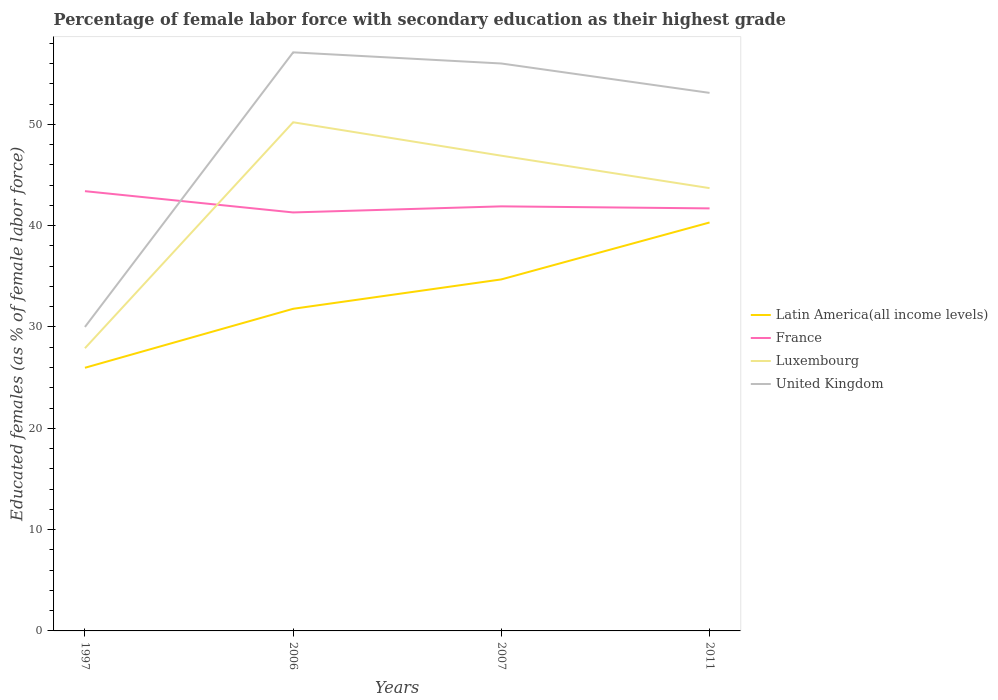How many different coloured lines are there?
Provide a succinct answer. 4. Is the number of lines equal to the number of legend labels?
Provide a succinct answer. Yes. Across all years, what is the maximum percentage of female labor force with secondary education in Latin America(all income levels)?
Your answer should be very brief. 25.97. In which year was the percentage of female labor force with secondary education in France maximum?
Offer a very short reply. 2006. What is the total percentage of female labor force with secondary education in Luxembourg in the graph?
Your answer should be very brief. -15.8. What is the difference between the highest and the second highest percentage of female labor force with secondary education in United Kingdom?
Your answer should be compact. 27.1. What is the difference between the highest and the lowest percentage of female labor force with secondary education in United Kingdom?
Give a very brief answer. 3. How many years are there in the graph?
Provide a succinct answer. 4. Are the values on the major ticks of Y-axis written in scientific E-notation?
Provide a short and direct response. No. Does the graph contain grids?
Your answer should be very brief. No. Where does the legend appear in the graph?
Provide a short and direct response. Center right. How many legend labels are there?
Provide a short and direct response. 4. How are the legend labels stacked?
Your response must be concise. Vertical. What is the title of the graph?
Provide a short and direct response. Percentage of female labor force with secondary education as their highest grade. What is the label or title of the Y-axis?
Provide a short and direct response. Educated females (as % of female labor force). What is the Educated females (as % of female labor force) of Latin America(all income levels) in 1997?
Your answer should be very brief. 25.97. What is the Educated females (as % of female labor force) in France in 1997?
Your answer should be very brief. 43.4. What is the Educated females (as % of female labor force) of Luxembourg in 1997?
Keep it short and to the point. 27.9. What is the Educated females (as % of female labor force) of Latin America(all income levels) in 2006?
Keep it short and to the point. 31.79. What is the Educated females (as % of female labor force) in France in 2006?
Your response must be concise. 41.3. What is the Educated females (as % of female labor force) of Luxembourg in 2006?
Your answer should be compact. 50.2. What is the Educated females (as % of female labor force) in United Kingdom in 2006?
Offer a terse response. 57.1. What is the Educated females (as % of female labor force) in Latin America(all income levels) in 2007?
Your answer should be compact. 34.69. What is the Educated females (as % of female labor force) of France in 2007?
Your answer should be very brief. 41.9. What is the Educated females (as % of female labor force) in Luxembourg in 2007?
Offer a very short reply. 46.9. What is the Educated females (as % of female labor force) of Latin America(all income levels) in 2011?
Give a very brief answer. 40.31. What is the Educated females (as % of female labor force) of France in 2011?
Offer a very short reply. 41.7. What is the Educated females (as % of female labor force) of Luxembourg in 2011?
Provide a succinct answer. 43.7. What is the Educated females (as % of female labor force) of United Kingdom in 2011?
Offer a very short reply. 53.1. Across all years, what is the maximum Educated females (as % of female labor force) in Latin America(all income levels)?
Ensure brevity in your answer.  40.31. Across all years, what is the maximum Educated females (as % of female labor force) in France?
Your answer should be compact. 43.4. Across all years, what is the maximum Educated females (as % of female labor force) of Luxembourg?
Your response must be concise. 50.2. Across all years, what is the maximum Educated females (as % of female labor force) in United Kingdom?
Give a very brief answer. 57.1. Across all years, what is the minimum Educated females (as % of female labor force) in Latin America(all income levels)?
Keep it short and to the point. 25.97. Across all years, what is the minimum Educated females (as % of female labor force) in France?
Provide a short and direct response. 41.3. Across all years, what is the minimum Educated females (as % of female labor force) in Luxembourg?
Provide a succinct answer. 27.9. Across all years, what is the minimum Educated females (as % of female labor force) of United Kingdom?
Provide a succinct answer. 30. What is the total Educated females (as % of female labor force) of Latin America(all income levels) in the graph?
Give a very brief answer. 132.76. What is the total Educated females (as % of female labor force) in France in the graph?
Provide a succinct answer. 168.3. What is the total Educated females (as % of female labor force) of Luxembourg in the graph?
Provide a short and direct response. 168.7. What is the total Educated females (as % of female labor force) of United Kingdom in the graph?
Offer a very short reply. 196.2. What is the difference between the Educated females (as % of female labor force) in Latin America(all income levels) in 1997 and that in 2006?
Provide a succinct answer. -5.82. What is the difference between the Educated females (as % of female labor force) of France in 1997 and that in 2006?
Your answer should be very brief. 2.1. What is the difference between the Educated females (as % of female labor force) in Luxembourg in 1997 and that in 2006?
Give a very brief answer. -22.3. What is the difference between the Educated females (as % of female labor force) of United Kingdom in 1997 and that in 2006?
Provide a succinct answer. -27.1. What is the difference between the Educated females (as % of female labor force) of Latin America(all income levels) in 1997 and that in 2007?
Ensure brevity in your answer.  -8.72. What is the difference between the Educated females (as % of female labor force) in Latin America(all income levels) in 1997 and that in 2011?
Your answer should be very brief. -14.34. What is the difference between the Educated females (as % of female labor force) in Luxembourg in 1997 and that in 2011?
Provide a short and direct response. -15.8. What is the difference between the Educated females (as % of female labor force) in United Kingdom in 1997 and that in 2011?
Make the answer very short. -23.1. What is the difference between the Educated females (as % of female labor force) of Latin America(all income levels) in 2006 and that in 2007?
Provide a short and direct response. -2.9. What is the difference between the Educated females (as % of female labor force) in United Kingdom in 2006 and that in 2007?
Provide a succinct answer. 1.1. What is the difference between the Educated females (as % of female labor force) in Latin America(all income levels) in 2006 and that in 2011?
Your answer should be very brief. -8.52. What is the difference between the Educated females (as % of female labor force) in France in 2006 and that in 2011?
Offer a very short reply. -0.4. What is the difference between the Educated females (as % of female labor force) of Luxembourg in 2006 and that in 2011?
Provide a succinct answer. 6.5. What is the difference between the Educated females (as % of female labor force) of United Kingdom in 2006 and that in 2011?
Make the answer very short. 4. What is the difference between the Educated females (as % of female labor force) in Latin America(all income levels) in 2007 and that in 2011?
Provide a short and direct response. -5.62. What is the difference between the Educated females (as % of female labor force) of Luxembourg in 2007 and that in 2011?
Provide a succinct answer. 3.2. What is the difference between the Educated females (as % of female labor force) of United Kingdom in 2007 and that in 2011?
Offer a very short reply. 2.9. What is the difference between the Educated females (as % of female labor force) in Latin America(all income levels) in 1997 and the Educated females (as % of female labor force) in France in 2006?
Give a very brief answer. -15.33. What is the difference between the Educated females (as % of female labor force) of Latin America(all income levels) in 1997 and the Educated females (as % of female labor force) of Luxembourg in 2006?
Provide a short and direct response. -24.23. What is the difference between the Educated females (as % of female labor force) of Latin America(all income levels) in 1997 and the Educated females (as % of female labor force) of United Kingdom in 2006?
Keep it short and to the point. -31.13. What is the difference between the Educated females (as % of female labor force) in France in 1997 and the Educated females (as % of female labor force) in United Kingdom in 2006?
Provide a succinct answer. -13.7. What is the difference between the Educated females (as % of female labor force) in Luxembourg in 1997 and the Educated females (as % of female labor force) in United Kingdom in 2006?
Offer a very short reply. -29.2. What is the difference between the Educated females (as % of female labor force) in Latin America(all income levels) in 1997 and the Educated females (as % of female labor force) in France in 2007?
Make the answer very short. -15.93. What is the difference between the Educated females (as % of female labor force) in Latin America(all income levels) in 1997 and the Educated females (as % of female labor force) in Luxembourg in 2007?
Ensure brevity in your answer.  -20.93. What is the difference between the Educated females (as % of female labor force) of Latin America(all income levels) in 1997 and the Educated females (as % of female labor force) of United Kingdom in 2007?
Your answer should be very brief. -30.03. What is the difference between the Educated females (as % of female labor force) of Luxembourg in 1997 and the Educated females (as % of female labor force) of United Kingdom in 2007?
Offer a terse response. -28.1. What is the difference between the Educated females (as % of female labor force) in Latin America(all income levels) in 1997 and the Educated females (as % of female labor force) in France in 2011?
Offer a very short reply. -15.73. What is the difference between the Educated females (as % of female labor force) in Latin America(all income levels) in 1997 and the Educated females (as % of female labor force) in Luxembourg in 2011?
Offer a very short reply. -17.73. What is the difference between the Educated females (as % of female labor force) in Latin America(all income levels) in 1997 and the Educated females (as % of female labor force) in United Kingdom in 2011?
Ensure brevity in your answer.  -27.13. What is the difference between the Educated females (as % of female labor force) in France in 1997 and the Educated females (as % of female labor force) in Luxembourg in 2011?
Provide a succinct answer. -0.3. What is the difference between the Educated females (as % of female labor force) of Luxembourg in 1997 and the Educated females (as % of female labor force) of United Kingdom in 2011?
Your answer should be very brief. -25.2. What is the difference between the Educated females (as % of female labor force) in Latin America(all income levels) in 2006 and the Educated females (as % of female labor force) in France in 2007?
Your response must be concise. -10.11. What is the difference between the Educated females (as % of female labor force) in Latin America(all income levels) in 2006 and the Educated females (as % of female labor force) in Luxembourg in 2007?
Provide a succinct answer. -15.11. What is the difference between the Educated females (as % of female labor force) in Latin America(all income levels) in 2006 and the Educated females (as % of female labor force) in United Kingdom in 2007?
Your response must be concise. -24.21. What is the difference between the Educated females (as % of female labor force) of France in 2006 and the Educated females (as % of female labor force) of United Kingdom in 2007?
Provide a succinct answer. -14.7. What is the difference between the Educated females (as % of female labor force) in Luxembourg in 2006 and the Educated females (as % of female labor force) in United Kingdom in 2007?
Make the answer very short. -5.8. What is the difference between the Educated females (as % of female labor force) of Latin America(all income levels) in 2006 and the Educated females (as % of female labor force) of France in 2011?
Your response must be concise. -9.91. What is the difference between the Educated females (as % of female labor force) of Latin America(all income levels) in 2006 and the Educated females (as % of female labor force) of Luxembourg in 2011?
Provide a short and direct response. -11.91. What is the difference between the Educated females (as % of female labor force) of Latin America(all income levels) in 2006 and the Educated females (as % of female labor force) of United Kingdom in 2011?
Give a very brief answer. -21.31. What is the difference between the Educated females (as % of female labor force) of France in 2006 and the Educated females (as % of female labor force) of Luxembourg in 2011?
Keep it short and to the point. -2.4. What is the difference between the Educated females (as % of female labor force) of France in 2006 and the Educated females (as % of female labor force) of United Kingdom in 2011?
Offer a terse response. -11.8. What is the difference between the Educated females (as % of female labor force) in Luxembourg in 2006 and the Educated females (as % of female labor force) in United Kingdom in 2011?
Your response must be concise. -2.9. What is the difference between the Educated females (as % of female labor force) of Latin America(all income levels) in 2007 and the Educated females (as % of female labor force) of France in 2011?
Ensure brevity in your answer.  -7.01. What is the difference between the Educated females (as % of female labor force) in Latin America(all income levels) in 2007 and the Educated females (as % of female labor force) in Luxembourg in 2011?
Offer a terse response. -9.01. What is the difference between the Educated females (as % of female labor force) in Latin America(all income levels) in 2007 and the Educated females (as % of female labor force) in United Kingdom in 2011?
Your response must be concise. -18.41. What is the difference between the Educated females (as % of female labor force) of France in 2007 and the Educated females (as % of female labor force) of United Kingdom in 2011?
Provide a succinct answer. -11.2. What is the average Educated females (as % of female labor force) of Latin America(all income levels) per year?
Provide a succinct answer. 33.19. What is the average Educated females (as % of female labor force) in France per year?
Offer a very short reply. 42.08. What is the average Educated females (as % of female labor force) in Luxembourg per year?
Give a very brief answer. 42.17. What is the average Educated females (as % of female labor force) of United Kingdom per year?
Your answer should be compact. 49.05. In the year 1997, what is the difference between the Educated females (as % of female labor force) of Latin America(all income levels) and Educated females (as % of female labor force) of France?
Offer a very short reply. -17.43. In the year 1997, what is the difference between the Educated females (as % of female labor force) in Latin America(all income levels) and Educated females (as % of female labor force) in Luxembourg?
Your answer should be very brief. -1.93. In the year 1997, what is the difference between the Educated females (as % of female labor force) in Latin America(all income levels) and Educated females (as % of female labor force) in United Kingdom?
Your answer should be very brief. -4.03. In the year 2006, what is the difference between the Educated females (as % of female labor force) of Latin America(all income levels) and Educated females (as % of female labor force) of France?
Give a very brief answer. -9.51. In the year 2006, what is the difference between the Educated females (as % of female labor force) in Latin America(all income levels) and Educated females (as % of female labor force) in Luxembourg?
Offer a very short reply. -18.41. In the year 2006, what is the difference between the Educated females (as % of female labor force) of Latin America(all income levels) and Educated females (as % of female labor force) of United Kingdom?
Make the answer very short. -25.31. In the year 2006, what is the difference between the Educated females (as % of female labor force) in France and Educated females (as % of female labor force) in United Kingdom?
Offer a terse response. -15.8. In the year 2007, what is the difference between the Educated females (as % of female labor force) of Latin America(all income levels) and Educated females (as % of female labor force) of France?
Offer a terse response. -7.21. In the year 2007, what is the difference between the Educated females (as % of female labor force) in Latin America(all income levels) and Educated females (as % of female labor force) in Luxembourg?
Offer a terse response. -12.21. In the year 2007, what is the difference between the Educated females (as % of female labor force) in Latin America(all income levels) and Educated females (as % of female labor force) in United Kingdom?
Provide a short and direct response. -21.31. In the year 2007, what is the difference between the Educated females (as % of female labor force) of France and Educated females (as % of female labor force) of United Kingdom?
Give a very brief answer. -14.1. In the year 2011, what is the difference between the Educated females (as % of female labor force) in Latin America(all income levels) and Educated females (as % of female labor force) in France?
Your response must be concise. -1.39. In the year 2011, what is the difference between the Educated females (as % of female labor force) of Latin America(all income levels) and Educated females (as % of female labor force) of Luxembourg?
Make the answer very short. -3.39. In the year 2011, what is the difference between the Educated females (as % of female labor force) in Latin America(all income levels) and Educated females (as % of female labor force) in United Kingdom?
Ensure brevity in your answer.  -12.79. In the year 2011, what is the difference between the Educated females (as % of female labor force) in France and Educated females (as % of female labor force) in Luxembourg?
Ensure brevity in your answer.  -2. In the year 2011, what is the difference between the Educated females (as % of female labor force) in Luxembourg and Educated females (as % of female labor force) in United Kingdom?
Your answer should be very brief. -9.4. What is the ratio of the Educated females (as % of female labor force) in Latin America(all income levels) in 1997 to that in 2006?
Ensure brevity in your answer.  0.82. What is the ratio of the Educated females (as % of female labor force) of France in 1997 to that in 2006?
Your answer should be compact. 1.05. What is the ratio of the Educated females (as % of female labor force) of Luxembourg in 1997 to that in 2006?
Your answer should be compact. 0.56. What is the ratio of the Educated females (as % of female labor force) of United Kingdom in 1997 to that in 2006?
Provide a succinct answer. 0.53. What is the ratio of the Educated females (as % of female labor force) of Latin America(all income levels) in 1997 to that in 2007?
Ensure brevity in your answer.  0.75. What is the ratio of the Educated females (as % of female labor force) of France in 1997 to that in 2007?
Your answer should be very brief. 1.04. What is the ratio of the Educated females (as % of female labor force) in Luxembourg in 1997 to that in 2007?
Make the answer very short. 0.59. What is the ratio of the Educated females (as % of female labor force) in United Kingdom in 1997 to that in 2007?
Keep it short and to the point. 0.54. What is the ratio of the Educated females (as % of female labor force) in Latin America(all income levels) in 1997 to that in 2011?
Provide a succinct answer. 0.64. What is the ratio of the Educated females (as % of female labor force) in France in 1997 to that in 2011?
Your answer should be very brief. 1.04. What is the ratio of the Educated females (as % of female labor force) of Luxembourg in 1997 to that in 2011?
Provide a succinct answer. 0.64. What is the ratio of the Educated females (as % of female labor force) of United Kingdom in 1997 to that in 2011?
Ensure brevity in your answer.  0.56. What is the ratio of the Educated females (as % of female labor force) of Latin America(all income levels) in 2006 to that in 2007?
Your answer should be very brief. 0.92. What is the ratio of the Educated females (as % of female labor force) in France in 2006 to that in 2007?
Your response must be concise. 0.99. What is the ratio of the Educated females (as % of female labor force) in Luxembourg in 2006 to that in 2007?
Your response must be concise. 1.07. What is the ratio of the Educated females (as % of female labor force) in United Kingdom in 2006 to that in 2007?
Provide a succinct answer. 1.02. What is the ratio of the Educated females (as % of female labor force) in Latin America(all income levels) in 2006 to that in 2011?
Keep it short and to the point. 0.79. What is the ratio of the Educated females (as % of female labor force) of Luxembourg in 2006 to that in 2011?
Make the answer very short. 1.15. What is the ratio of the Educated females (as % of female labor force) in United Kingdom in 2006 to that in 2011?
Provide a succinct answer. 1.08. What is the ratio of the Educated females (as % of female labor force) of Latin America(all income levels) in 2007 to that in 2011?
Provide a succinct answer. 0.86. What is the ratio of the Educated females (as % of female labor force) of France in 2007 to that in 2011?
Provide a succinct answer. 1. What is the ratio of the Educated females (as % of female labor force) of Luxembourg in 2007 to that in 2011?
Ensure brevity in your answer.  1.07. What is the ratio of the Educated females (as % of female labor force) of United Kingdom in 2007 to that in 2011?
Your response must be concise. 1.05. What is the difference between the highest and the second highest Educated females (as % of female labor force) in Latin America(all income levels)?
Offer a very short reply. 5.62. What is the difference between the highest and the second highest Educated females (as % of female labor force) of France?
Your answer should be compact. 1.5. What is the difference between the highest and the second highest Educated females (as % of female labor force) of Luxembourg?
Your response must be concise. 3.3. What is the difference between the highest and the second highest Educated females (as % of female labor force) in United Kingdom?
Offer a terse response. 1.1. What is the difference between the highest and the lowest Educated females (as % of female labor force) in Latin America(all income levels)?
Your answer should be very brief. 14.34. What is the difference between the highest and the lowest Educated females (as % of female labor force) of France?
Your answer should be compact. 2.1. What is the difference between the highest and the lowest Educated females (as % of female labor force) in Luxembourg?
Provide a succinct answer. 22.3. What is the difference between the highest and the lowest Educated females (as % of female labor force) of United Kingdom?
Your answer should be compact. 27.1. 